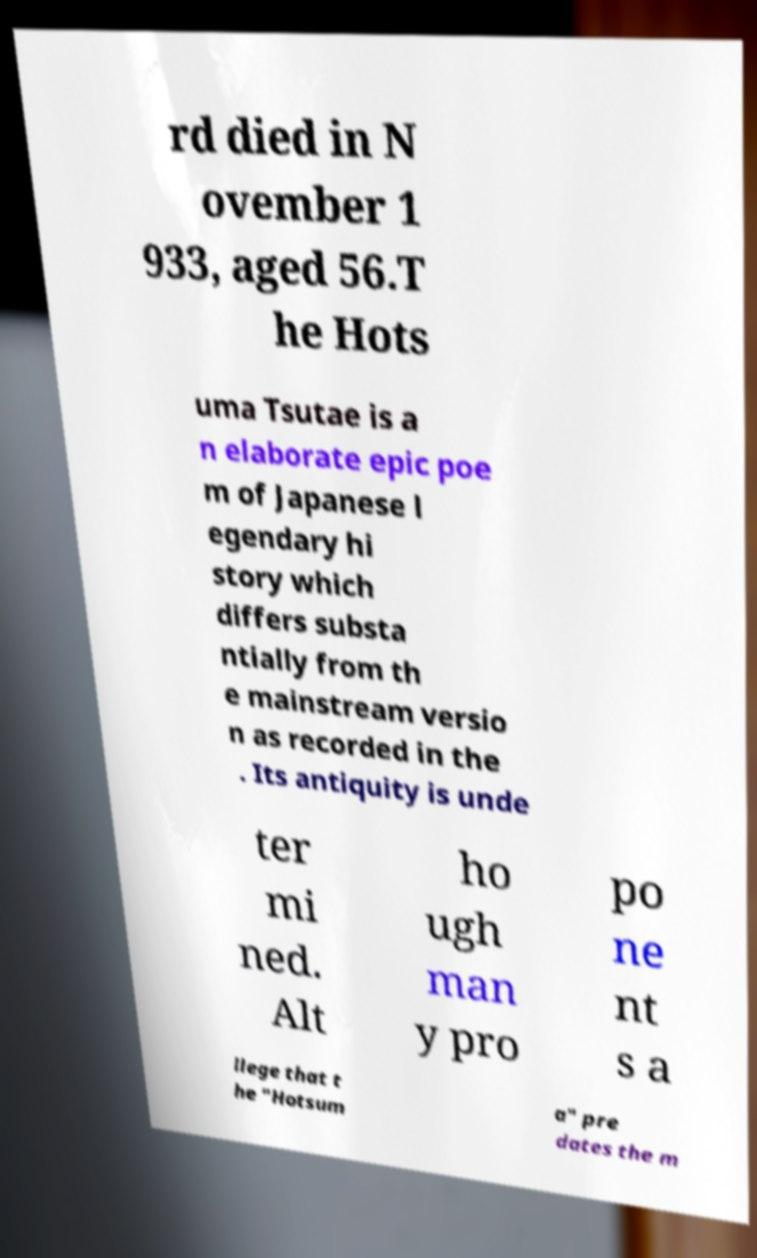Please read and relay the text visible in this image. What does it say? rd died in N ovember 1 933, aged 56.T he Hots uma Tsutae is a n elaborate epic poe m of Japanese l egendary hi story which differs substa ntially from th e mainstream versio n as recorded in the . Its antiquity is unde ter mi ned. Alt ho ugh man y pro po ne nt s a llege that t he "Hotsum a" pre dates the m 